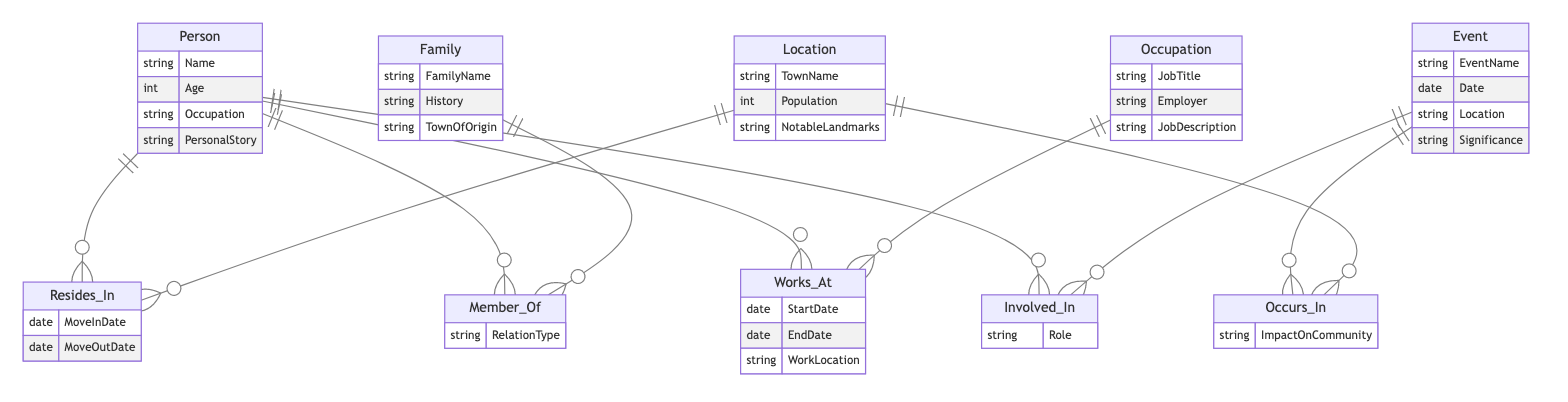What is the primary entity representing individuals in the diagram? The primary entity depicting individuals in the diagram is labeled "Person," as it features attributes like "Name," "Age," "Occupation," and "PersonalStory" directly associated with it.
Answer: Person How many entities are present in the diagram? The diagram contains five unique entities: Person, Family, Event, Location, and Occupation, which can be directly counted from the entities section of the diagram.
Answer: 5 What relationship connects Person and Family? The relationship linking "Person" and "Family" is named "Member_Of," which indicates that individuals can be members of families in the context of the diagram's narrative.
Answer: Member_Of What attribute describes when a person moves into or out of a location? The attributes defining the move-in and move-out dates in the relationship between "Person" and "Location" are "MoveInDate" and "MoveOutDate."
Answer: MoveInDate, MoveOutDate Which entity depicts the events that occur in the town? The "Event" entity shows the significant occurrences happening in the town, as evidenced by its attributes like "EventName," "Date," "Location," and "Significance."
Answer: Event What attribute represents the job title of a person? Within the "Occupation" entity, the attribute "JobTitle" specifically denotes the title of the job held by a person, directly associated with their role in the community.
Answer: JobTitle How are events and locations correlated in the diagram? The relationship titled "Occurs_In" connects the "Event" entity to the "Location" entity, suggesting that events take place in specified locations and include the attribute "ImpactOnCommunity."
Answer: Occurs_In What is the role of a person concerning events? The relationship known as "Involved_In" defines how a person participates in events, with the attribute "Role" providing insight into their specific involvement in those events.
Answer: Involved_In What relationship indicates where a person works? The "Works_At" relationship establishes the connection between a "Person" and their "Occupation," clarifying the workplace details of the individual.
Answer: Works_At 